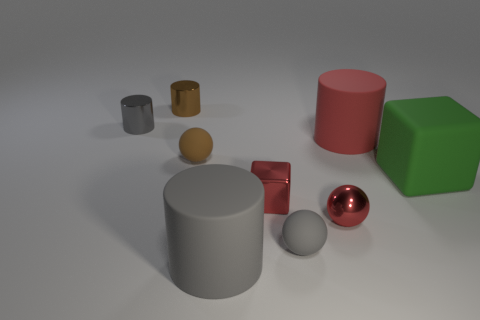Which objects in the image are most reflective? The small red sphere and the tiny brown cylinder are the most reflective objects in the image, both showing clear highlights that indicate a glossy surface. 